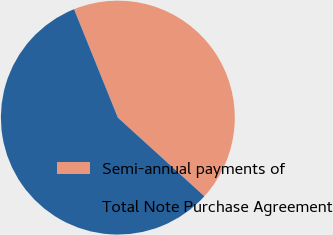<chart> <loc_0><loc_0><loc_500><loc_500><pie_chart><fcel>Semi-annual payments of<fcel>Total Note Purchase Agreement<nl><fcel>42.86%<fcel>57.14%<nl></chart> 